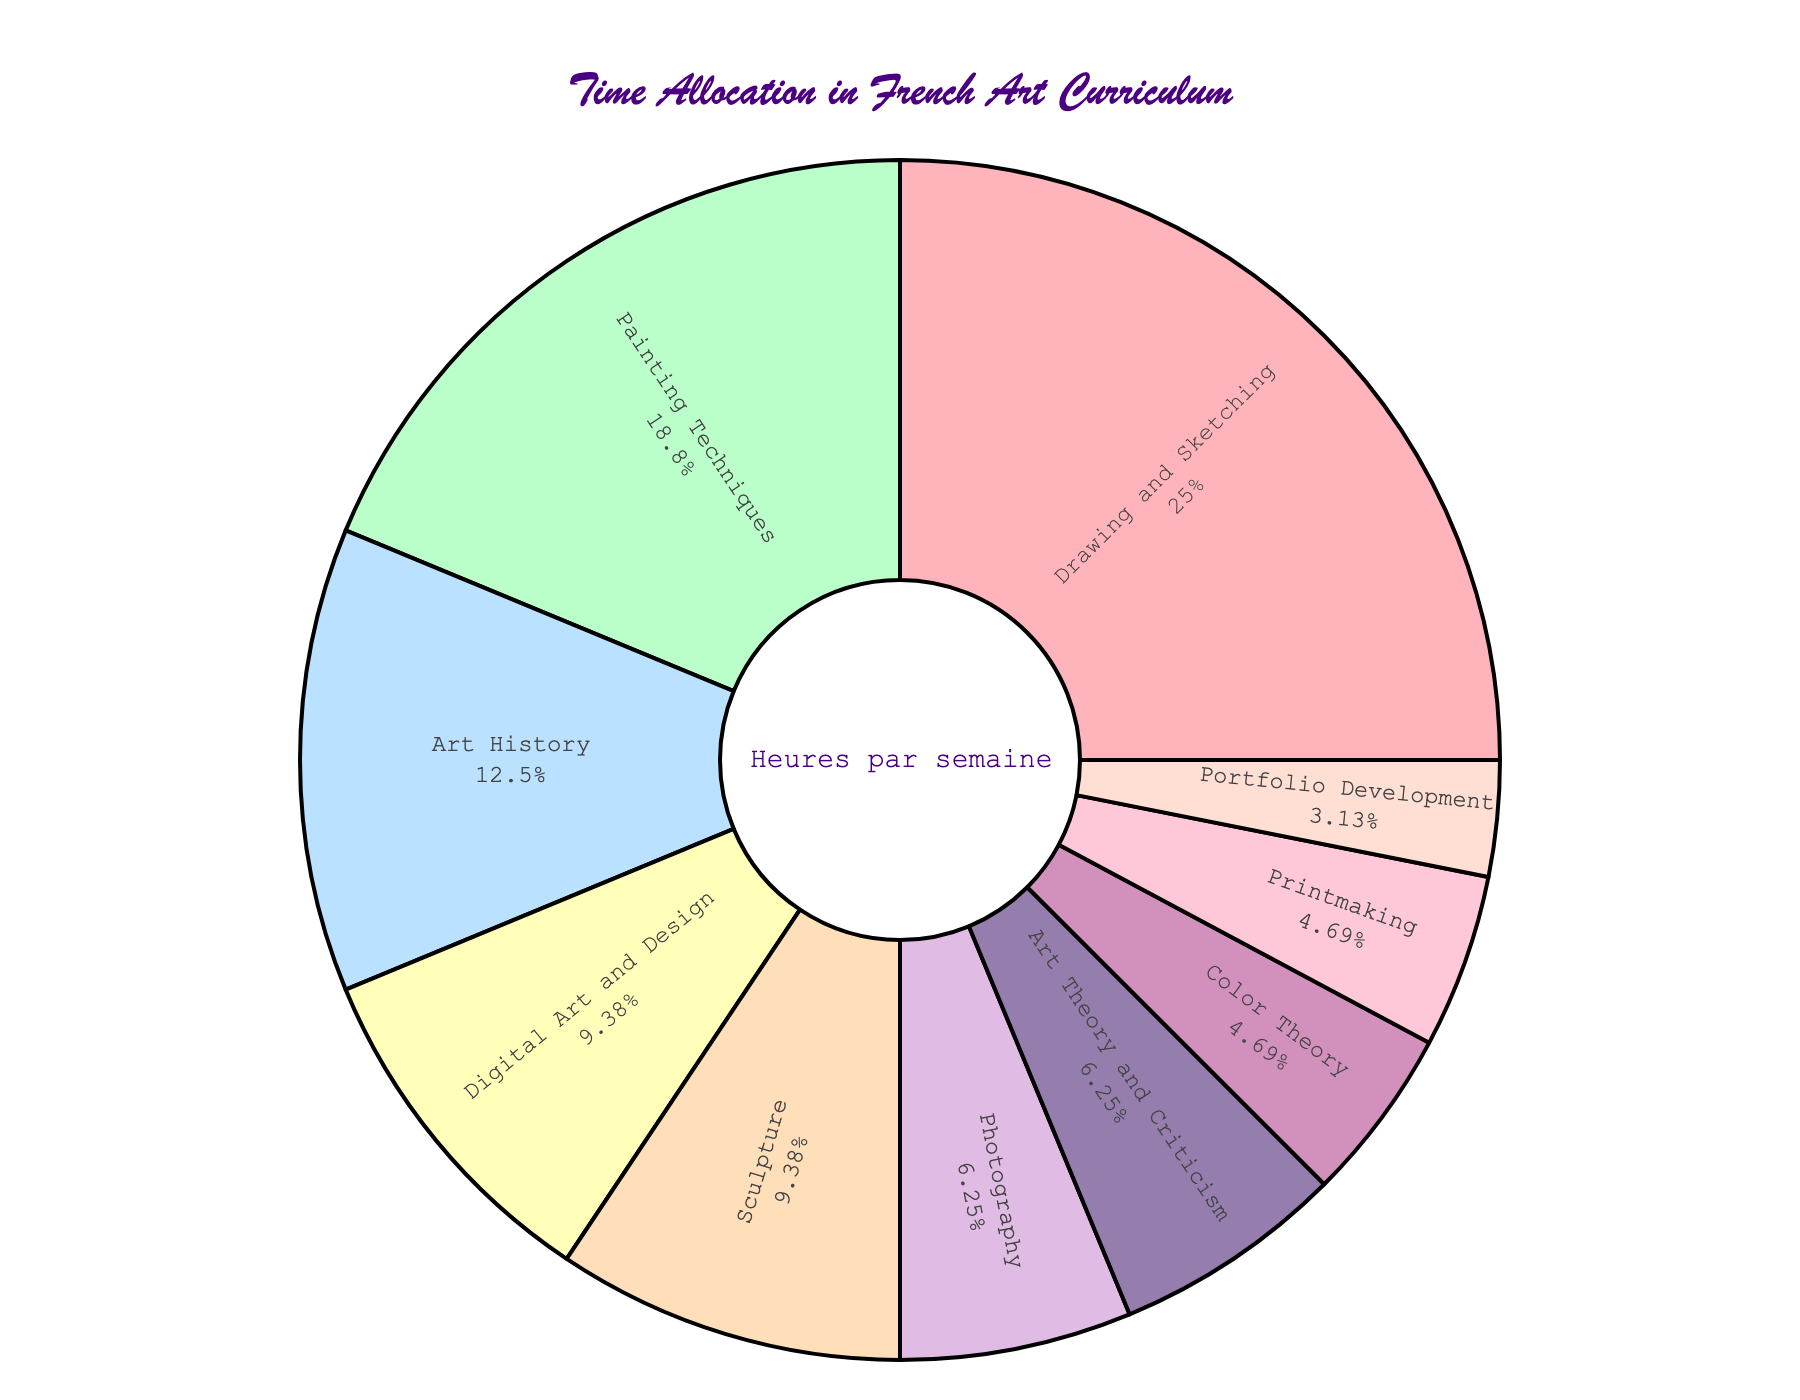How many more hours per week are allocated to Drawing and Sketching compared to Portfolio Development? Drawing and Sketching is allocated 8 hours per week, and Portfolio Development is allocated 1 hour per week. The difference is 8 - 1 = 7 hours.
Answer: 7 Which subject takes up the most time each week? By observing the pie chart, Drawing and Sketching has the largest portion, taking up 8 hours per week.
Answer: Drawing and Sketching If you combined the hours for Art History and Art Theory and Criticism, how much time would be allocated? Art History is allocated 4 hours, and Art Theory and Criticism is allocated 2 hours. Combined, they take up 4 + 2 = 6 hours.
Answer: 6 How many subjects have 3 or more hours allocated to them each week? Subjects with 3 or more hours are Drawing and Sketching (8), Painting Techniques (6), Art History (4), Digital Art and Design (3), and Sculpture (3). There are 5 such subjects.
Answer: 5 Are there more hours allocated to Photography or to Printmaking? Photography is allocated 2 hours per week, while Printmaking is allocated 1.5 hours per week. Photography has more hours.
Answer: Photography What percentage of the total weekly hours is allocated to Sculpture? Sculpture is allocated 3 hours. The total is 31 hours per week. The percentage is (3/31) * 100 ≈ 9.68%.
Answer: ≈ 9.68% How do the hours for Digital Art and Design compare to those for Photography? Digital Art and Design has 3 hours, and Photography has 2 hours. Digital Art and Design has 1 hour more than Photography.
Answer: 1 hour more Which subject occupies the smallest portion of the pie chart? Portfolio Development has the smallest portion with 1 hour per week.
Answer: Portfolio Development What is the total time allocated to subjects related to practical skills (Drawing and Sketching, Painting Techniques, Sculpture, Printmaking)? Drawing and Sketching (8) + Painting Techniques (6) + Sculpture (3) + Printmaking (1.5) = 18.5 hours.
Answer: 18.5 What is the difference in time allocation between the two subjects with the closest allocation? Color Theory and Printmaking both have 1.5 hours allocated per week, so the difference is 0 hours.
Answer: 0 